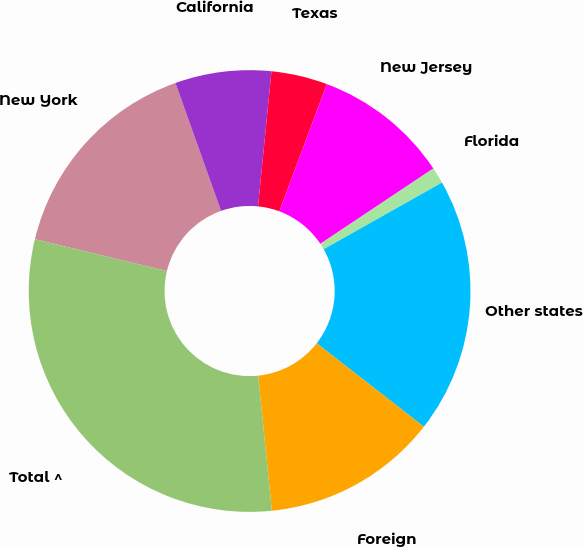Convert chart to OTSL. <chart><loc_0><loc_0><loc_500><loc_500><pie_chart><fcel>New York<fcel>California<fcel>Texas<fcel>New Jersey<fcel>Florida<fcel>Other states<fcel>Foreign<fcel>Total ^<nl><fcel>15.78%<fcel>7.03%<fcel>4.11%<fcel>9.95%<fcel>1.19%<fcel>18.7%<fcel>12.86%<fcel>30.38%<nl></chart> 